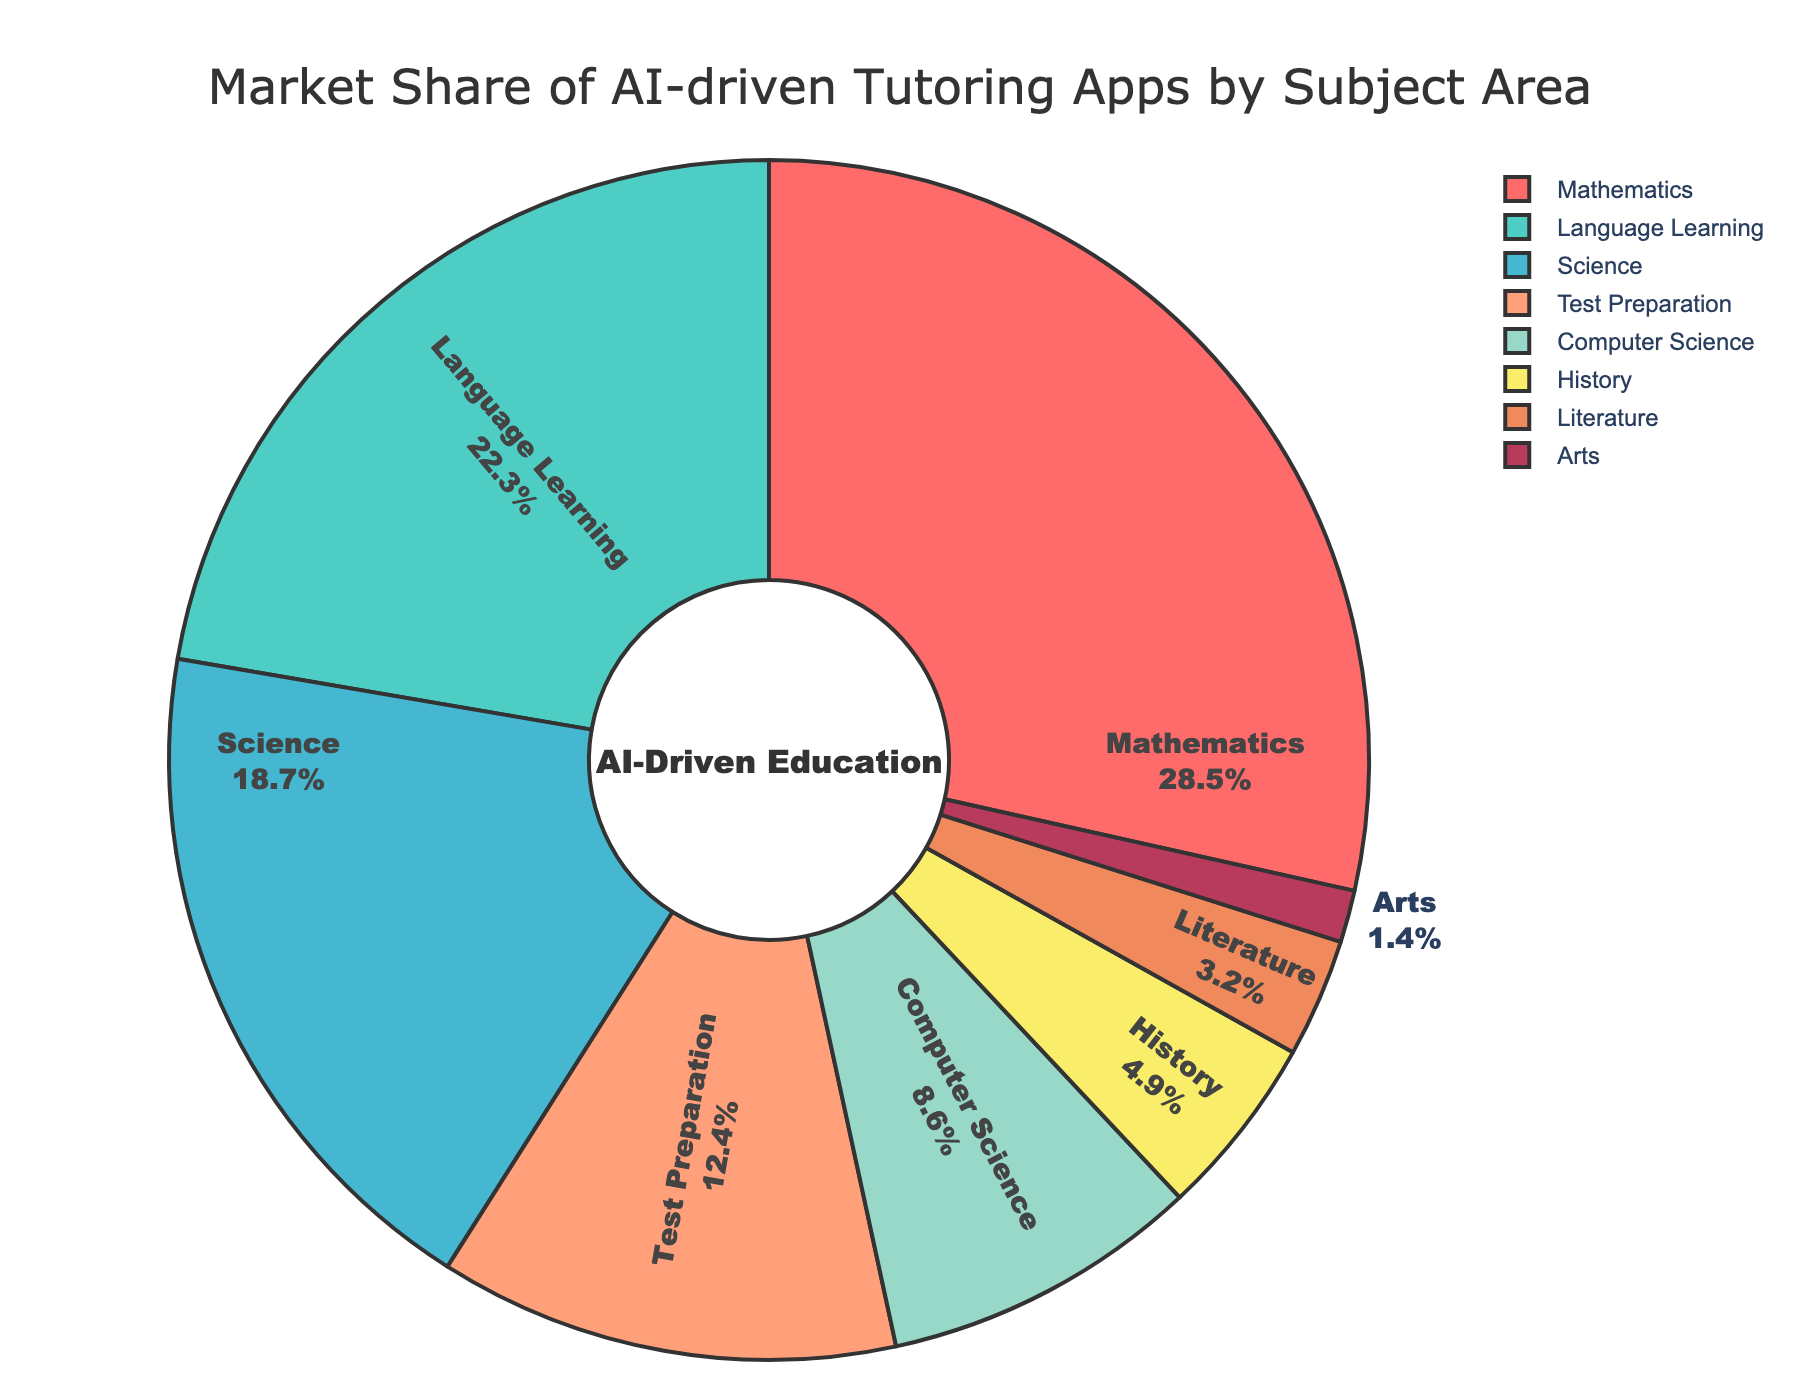What subject has the largest market share? The pie chart shows that Mathematics has the largest portion which appears the biggest among all segments.
Answer: Mathematics What is the combined market share of Science and Computer Science? The market share for Science is 18.7% and for Computer Science is 8.6%. Adding them together, we get 18.7% + 8.6% = 27.3%.
Answer: 27.3% Which two subjects have the smallest market share? The segments representing Literature and Arts are visually the smallest in the pie chart. Literature has 3.2% and Arts has 1.4%.
Answer: Literature and Arts How much larger is the market share of Mathematics compared to History? The market share for Mathematics is 28.5% and for History, it is 4.9%. The difference is 28.5% - 4.9% = 23.6%.
Answer: 23.6% What is the market share percentage difference between Language Learning and Test Preparation? The pie chart shows Language Learning at 22.3% and Test Preparation at 12.4%. The difference is 22.3% - 12.4% = 9.9%.
Answer: 9.9% What is the combined market share of the top three subjects? The top three subjects by market share are Mathematics (28.5%), Language Learning (22.3%), and Science (18.7%). Adding these up: 28.5% + 22.3% + 18.7% = 69.5%.
Answer: 69.5% Is the market share of Language Learning greater than that of Science and Computer Science combined? The market share for Language Learning is 22.3%. The combined market share for Science and Computer Science is 18.7% + 8.6% = 27.3%, which is greater than 22.3%.
Answer: No What color is used to represent the market share of Arts? The pie chart uses a unique color for each segment. The slice for Arts is identified with a purple color.
Answer: Purple 